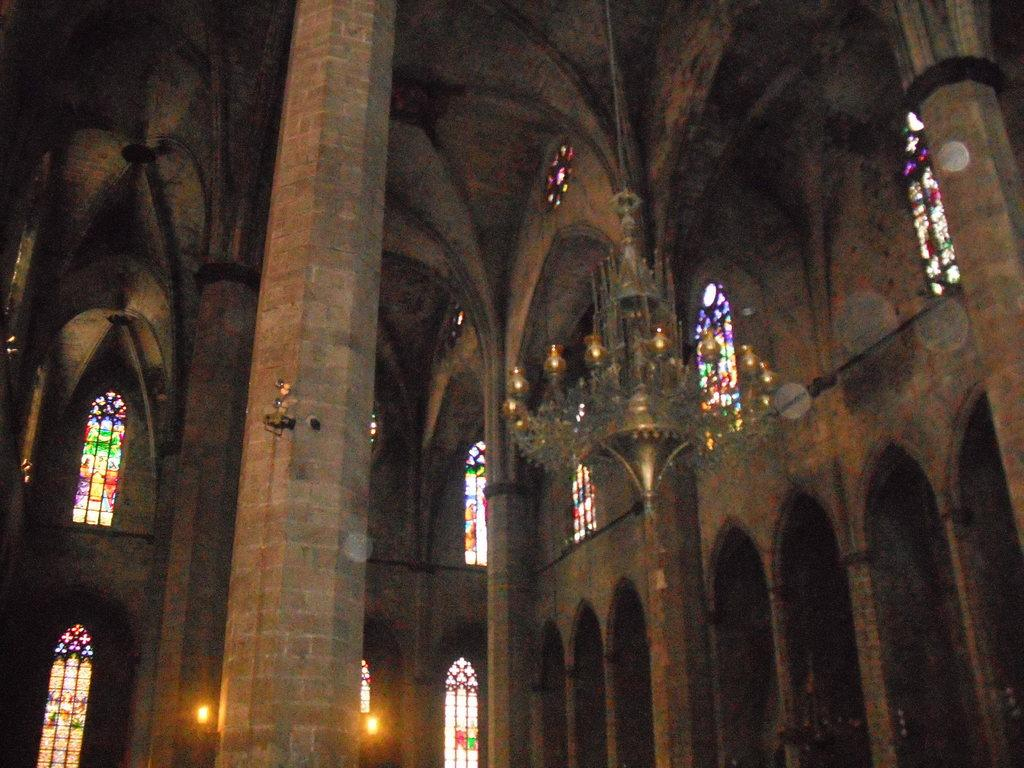What type of lighting fixture is present in the image? There is a chandelier in the image. What architectural features can be seen in the image? There are pillars in the image. What type of lighting is present in the image? There are lights in the image. What can be inferred about the location of the image? The image is an inside view of a building. What type of quill is used to write on the pillars in the image? There is no quill or writing present on the pillars in the image. What type of company might be operating in the building depicted in the image? The image does not provide any information about the type of company or its operations. 